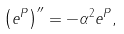Convert formula to latex. <formula><loc_0><loc_0><loc_500><loc_500>\left ( e ^ { P } \right ) ^ { \prime \prime } = - \alpha ^ { 2 } e ^ { P } ,</formula> 